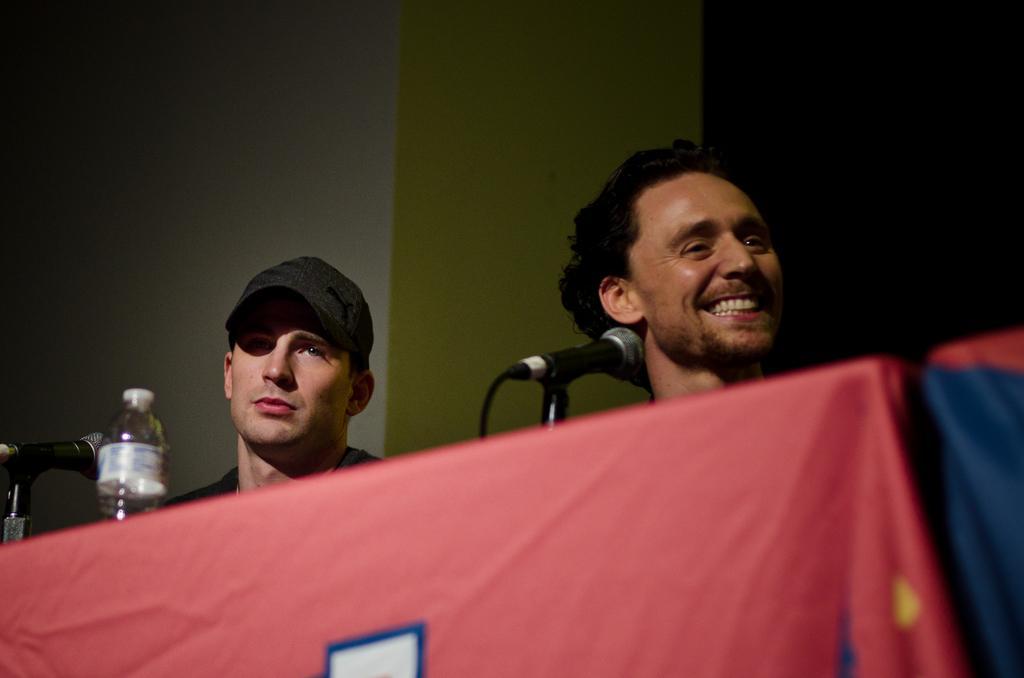In one or two sentences, can you explain what this image depicts? In this image I can see persons. In front of persons there is a cloth on the table. On the table there is a bottle and a mike. And at the background there is a wall. 